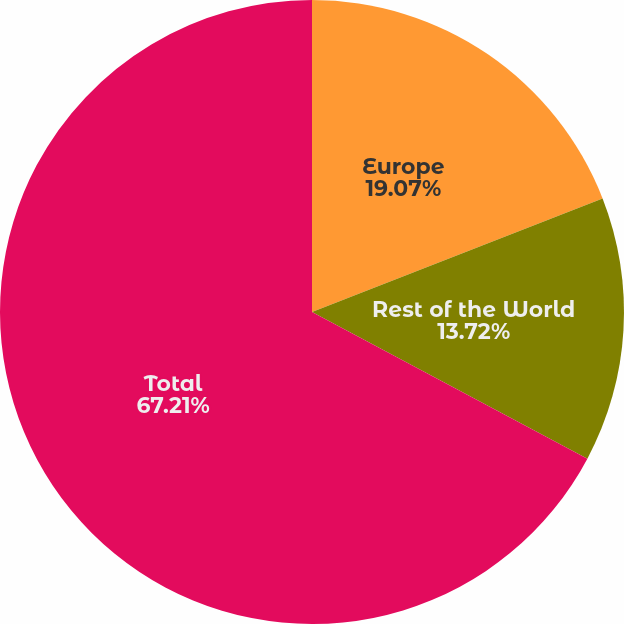Convert chart to OTSL. <chart><loc_0><loc_0><loc_500><loc_500><pie_chart><fcel>Europe<fcel>Rest of the World<fcel>Total<nl><fcel>19.07%<fcel>13.72%<fcel>67.22%<nl></chart> 